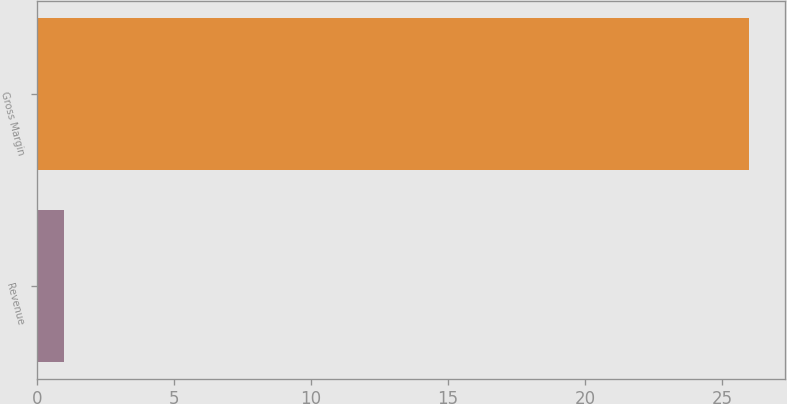Convert chart to OTSL. <chart><loc_0><loc_0><loc_500><loc_500><bar_chart><fcel>Revenue<fcel>Gross Margin<nl><fcel>1<fcel>26<nl></chart> 